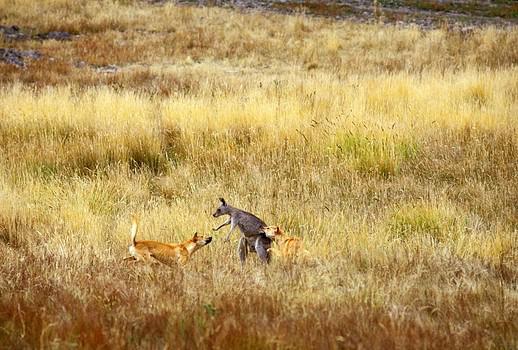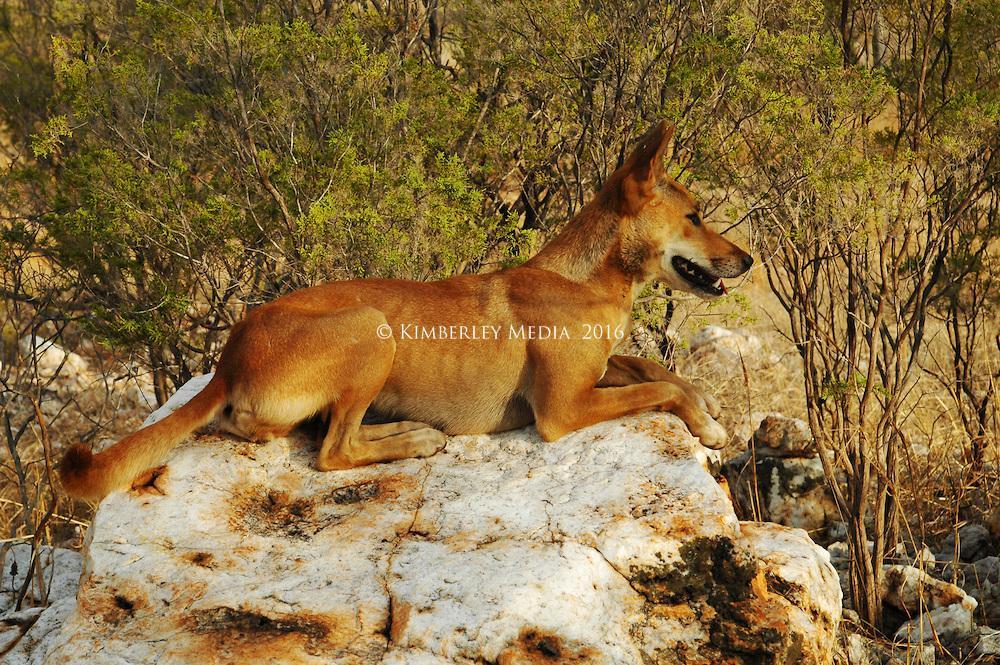The first image is the image on the left, the second image is the image on the right. Assess this claim about the two images: "A kangaroo is being attacked by two coyotes.". Correct or not? Answer yes or no. Yes. The first image is the image on the left, the second image is the image on the right. For the images shown, is this caption "An upright kangaroo is flanked by two attacking dingos in the image on the left." true? Answer yes or no. Yes. 